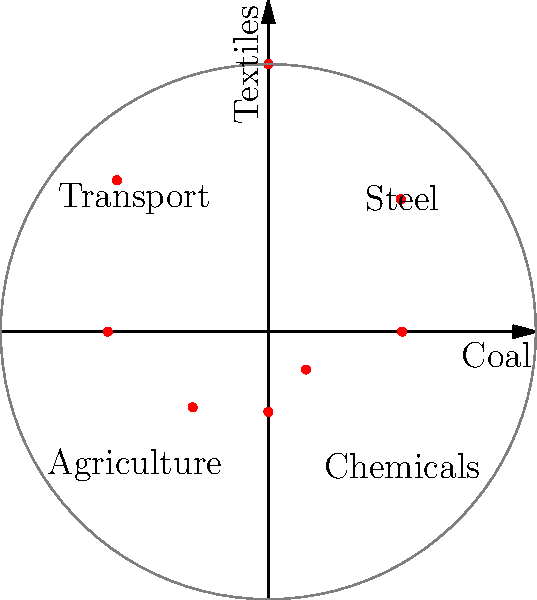In the polar graph above, economic growth rates of various industries during the Industrial Revolution are plotted. The radial distance represents the annual growth rate percentage, while the angular position represents different industries. Which industry shows the highest growth rate, and what is its approximate value? To answer this question, we need to follow these steps:

1. Understand the graph structure:
   - The radial distance from the center represents the growth rate percentage.
   - The angular position represents different industries.

2. Identify the industries:
   - The x-axis (0°) represents Coal
   - The y-axis (90°) represents Textiles
   - Other industries are labeled on the graph

3. Locate the point farthest from the center:
   - This point will represent the industry with the highest growth rate.
   - We can see that the point at 90° (on the y-axis) is farthest from the center.

4. Determine the industry and growth rate:
   - The point at 90° corresponds to the Textiles industry.
   - By estimating the radial distance, we can see it's approximately at the 10% mark.

Therefore, the Textiles industry shows the highest growth rate at approximately 10% annually during the Industrial Revolution period represented in this graph.
Answer: Textiles, approximately 10% 